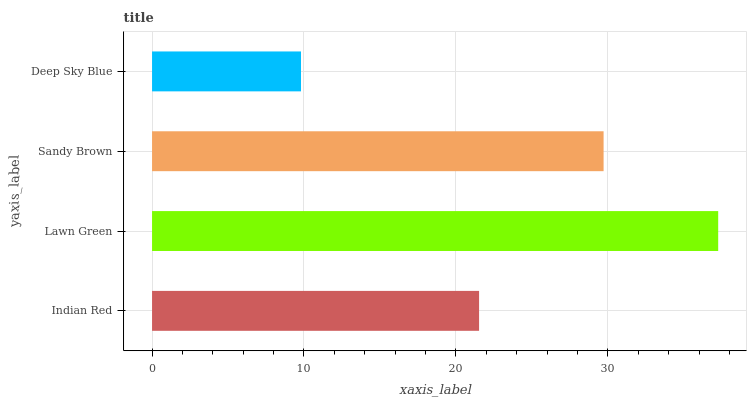Is Deep Sky Blue the minimum?
Answer yes or no. Yes. Is Lawn Green the maximum?
Answer yes or no. Yes. Is Sandy Brown the minimum?
Answer yes or no. No. Is Sandy Brown the maximum?
Answer yes or no. No. Is Lawn Green greater than Sandy Brown?
Answer yes or no. Yes. Is Sandy Brown less than Lawn Green?
Answer yes or no. Yes. Is Sandy Brown greater than Lawn Green?
Answer yes or no. No. Is Lawn Green less than Sandy Brown?
Answer yes or no. No. Is Sandy Brown the high median?
Answer yes or no. Yes. Is Indian Red the low median?
Answer yes or no. Yes. Is Indian Red the high median?
Answer yes or no. No. Is Sandy Brown the low median?
Answer yes or no. No. 